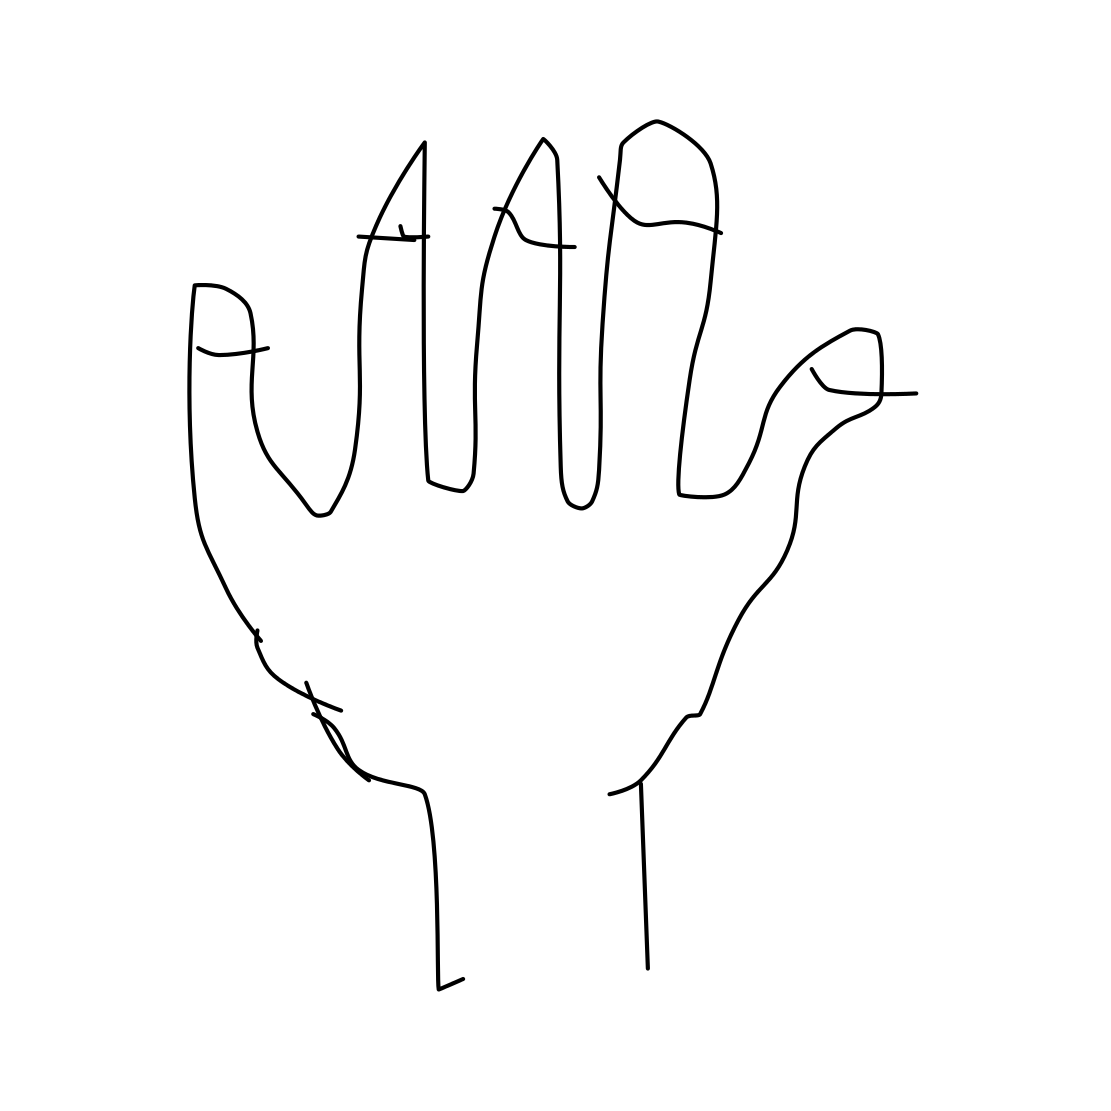How might this image be interpreted in a psychological test? In a psychological context, this image might be used as a projective test, similar to a Rorschach inkblot test, where individuals are asked to interpret the image. This could provide insights into their mental state or personality based on what they perceive in the simple lines and shapes of the drawing. 